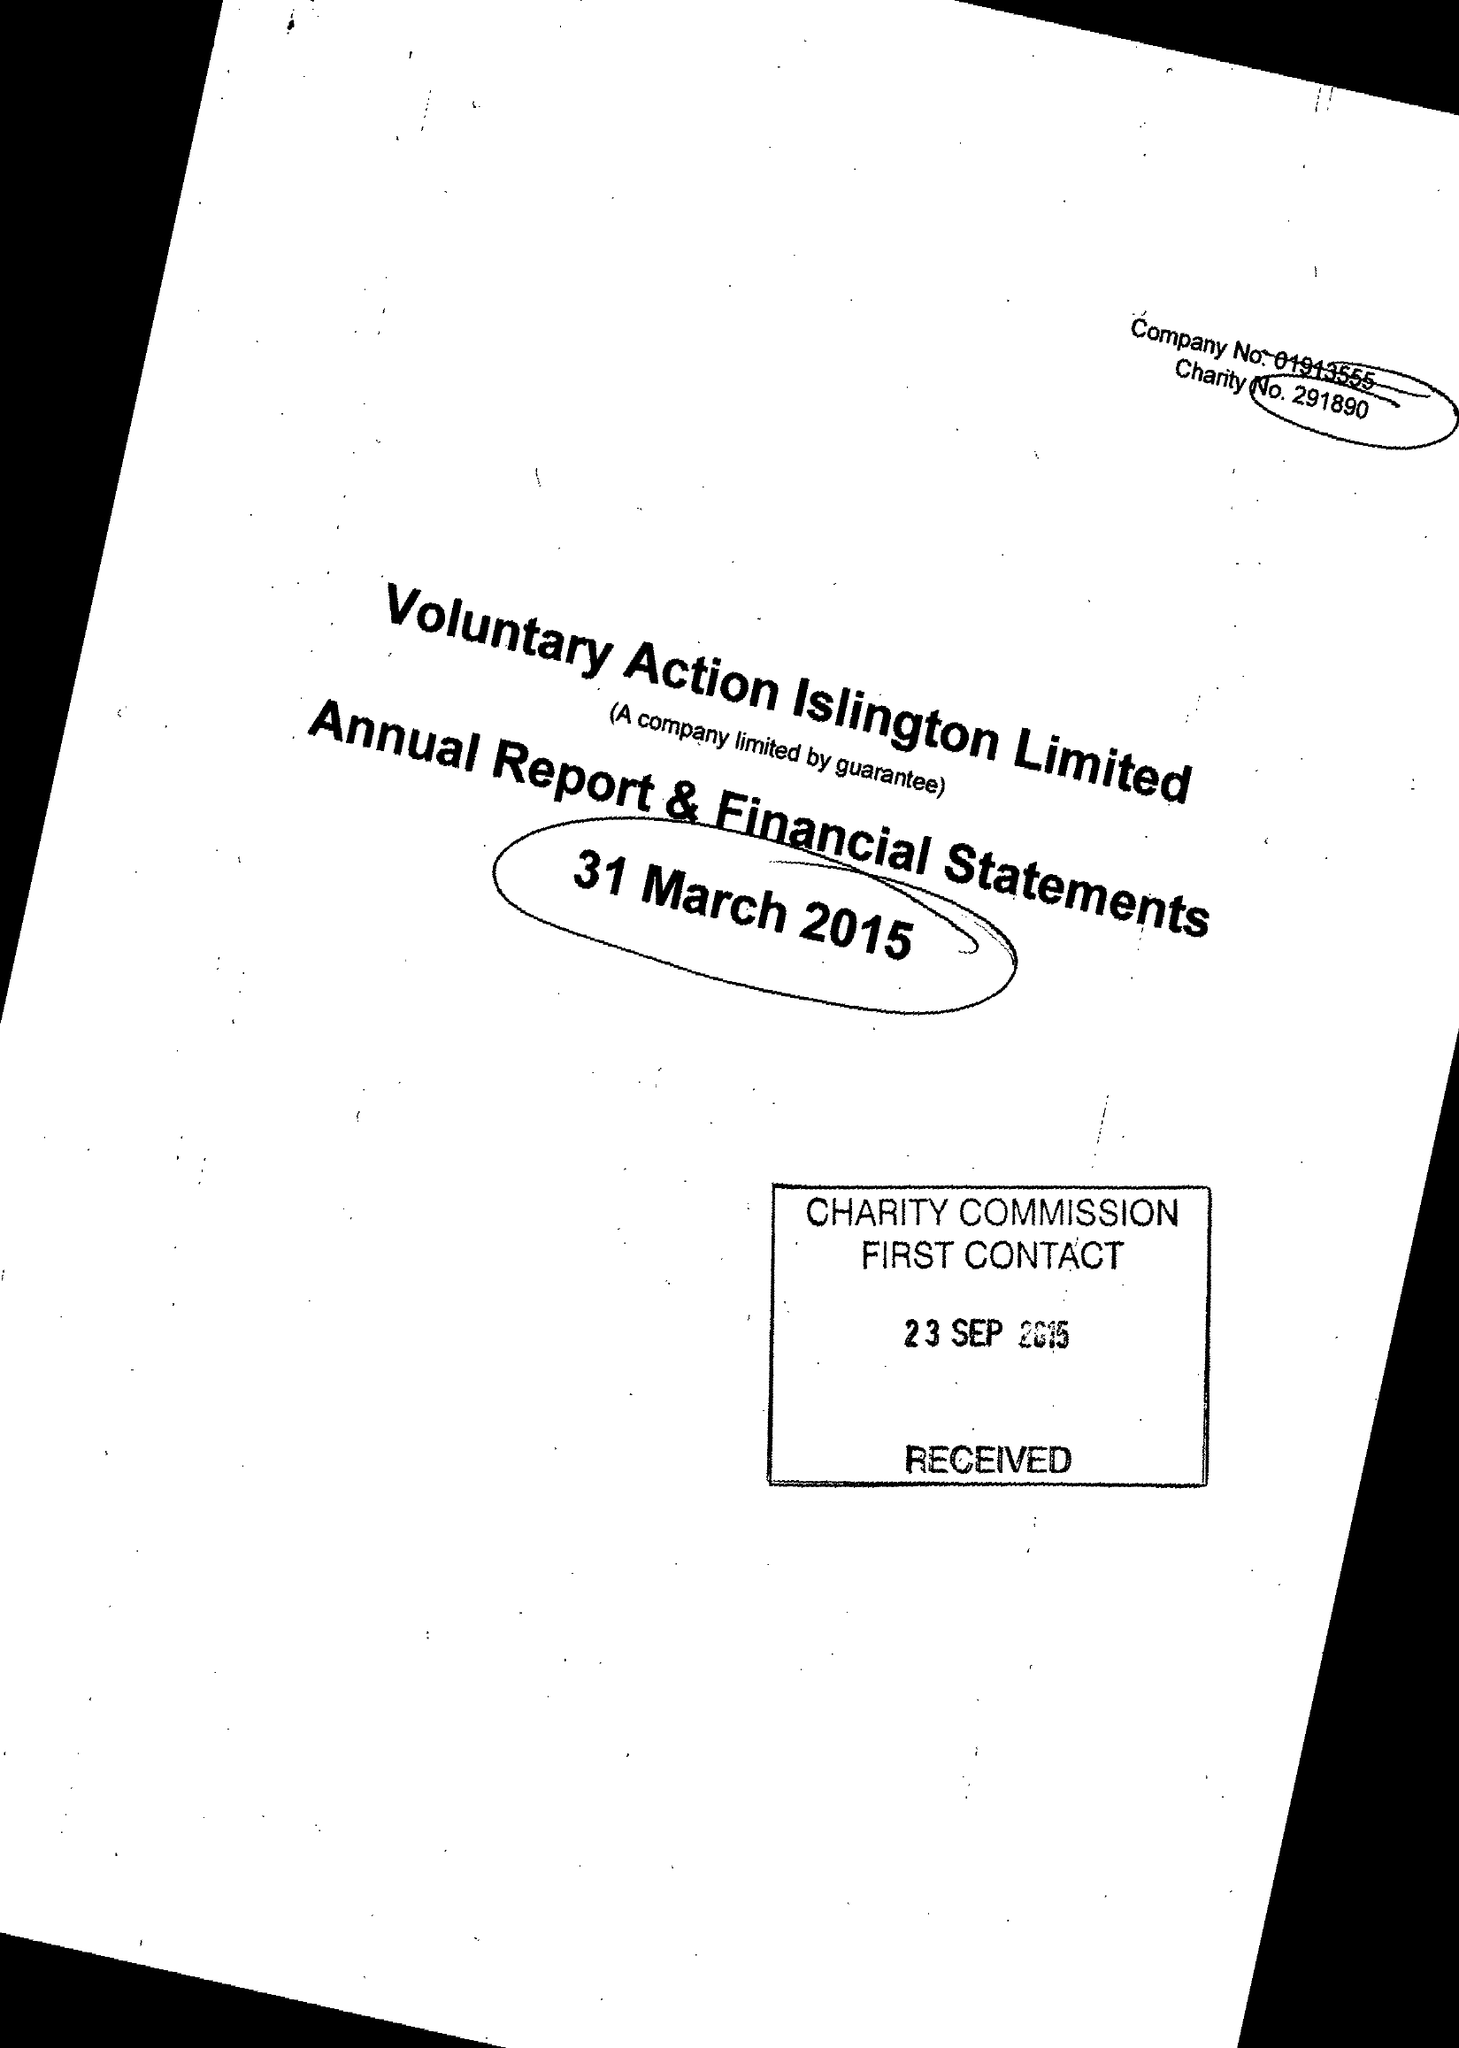What is the value for the income_annually_in_british_pounds?
Answer the question using a single word or phrase. 506793.00 